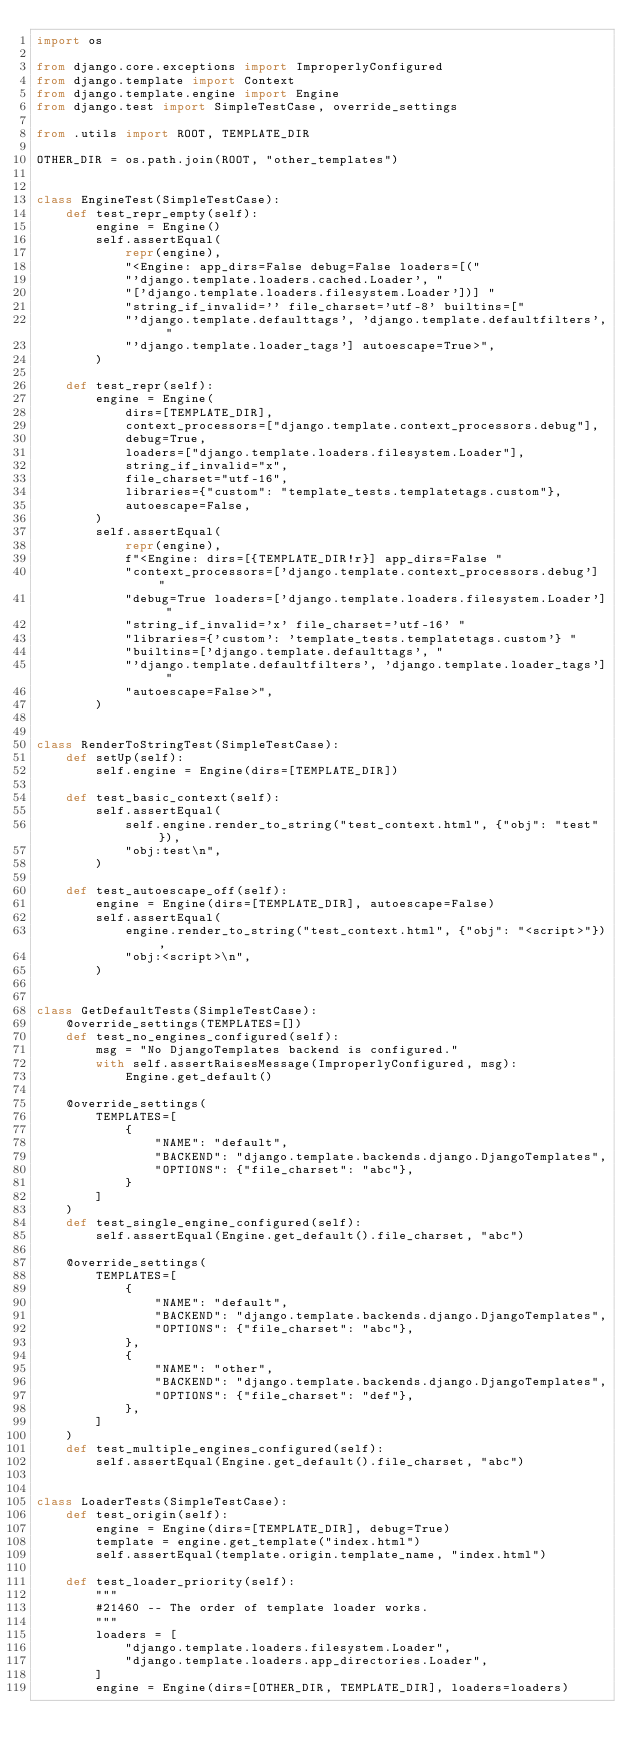Convert code to text. <code><loc_0><loc_0><loc_500><loc_500><_Python_>import os

from django.core.exceptions import ImproperlyConfigured
from django.template import Context
from django.template.engine import Engine
from django.test import SimpleTestCase, override_settings

from .utils import ROOT, TEMPLATE_DIR

OTHER_DIR = os.path.join(ROOT, "other_templates")


class EngineTest(SimpleTestCase):
    def test_repr_empty(self):
        engine = Engine()
        self.assertEqual(
            repr(engine),
            "<Engine: app_dirs=False debug=False loaders=[("
            "'django.template.loaders.cached.Loader', "
            "['django.template.loaders.filesystem.Loader'])] "
            "string_if_invalid='' file_charset='utf-8' builtins=["
            "'django.template.defaulttags', 'django.template.defaultfilters', "
            "'django.template.loader_tags'] autoescape=True>",
        )

    def test_repr(self):
        engine = Engine(
            dirs=[TEMPLATE_DIR],
            context_processors=["django.template.context_processors.debug"],
            debug=True,
            loaders=["django.template.loaders.filesystem.Loader"],
            string_if_invalid="x",
            file_charset="utf-16",
            libraries={"custom": "template_tests.templatetags.custom"},
            autoescape=False,
        )
        self.assertEqual(
            repr(engine),
            f"<Engine: dirs=[{TEMPLATE_DIR!r}] app_dirs=False "
            "context_processors=['django.template.context_processors.debug'] "
            "debug=True loaders=['django.template.loaders.filesystem.Loader'] "
            "string_if_invalid='x' file_charset='utf-16' "
            "libraries={'custom': 'template_tests.templatetags.custom'} "
            "builtins=['django.template.defaulttags', "
            "'django.template.defaultfilters', 'django.template.loader_tags'] "
            "autoescape=False>",
        )


class RenderToStringTest(SimpleTestCase):
    def setUp(self):
        self.engine = Engine(dirs=[TEMPLATE_DIR])

    def test_basic_context(self):
        self.assertEqual(
            self.engine.render_to_string("test_context.html", {"obj": "test"}),
            "obj:test\n",
        )

    def test_autoescape_off(self):
        engine = Engine(dirs=[TEMPLATE_DIR], autoescape=False)
        self.assertEqual(
            engine.render_to_string("test_context.html", {"obj": "<script>"}),
            "obj:<script>\n",
        )


class GetDefaultTests(SimpleTestCase):
    @override_settings(TEMPLATES=[])
    def test_no_engines_configured(self):
        msg = "No DjangoTemplates backend is configured."
        with self.assertRaisesMessage(ImproperlyConfigured, msg):
            Engine.get_default()

    @override_settings(
        TEMPLATES=[
            {
                "NAME": "default",
                "BACKEND": "django.template.backends.django.DjangoTemplates",
                "OPTIONS": {"file_charset": "abc"},
            }
        ]
    )
    def test_single_engine_configured(self):
        self.assertEqual(Engine.get_default().file_charset, "abc")

    @override_settings(
        TEMPLATES=[
            {
                "NAME": "default",
                "BACKEND": "django.template.backends.django.DjangoTemplates",
                "OPTIONS": {"file_charset": "abc"},
            },
            {
                "NAME": "other",
                "BACKEND": "django.template.backends.django.DjangoTemplates",
                "OPTIONS": {"file_charset": "def"},
            },
        ]
    )
    def test_multiple_engines_configured(self):
        self.assertEqual(Engine.get_default().file_charset, "abc")


class LoaderTests(SimpleTestCase):
    def test_origin(self):
        engine = Engine(dirs=[TEMPLATE_DIR], debug=True)
        template = engine.get_template("index.html")
        self.assertEqual(template.origin.template_name, "index.html")

    def test_loader_priority(self):
        """
        #21460 -- The order of template loader works.
        """
        loaders = [
            "django.template.loaders.filesystem.Loader",
            "django.template.loaders.app_directories.Loader",
        ]
        engine = Engine(dirs=[OTHER_DIR, TEMPLATE_DIR], loaders=loaders)</code> 